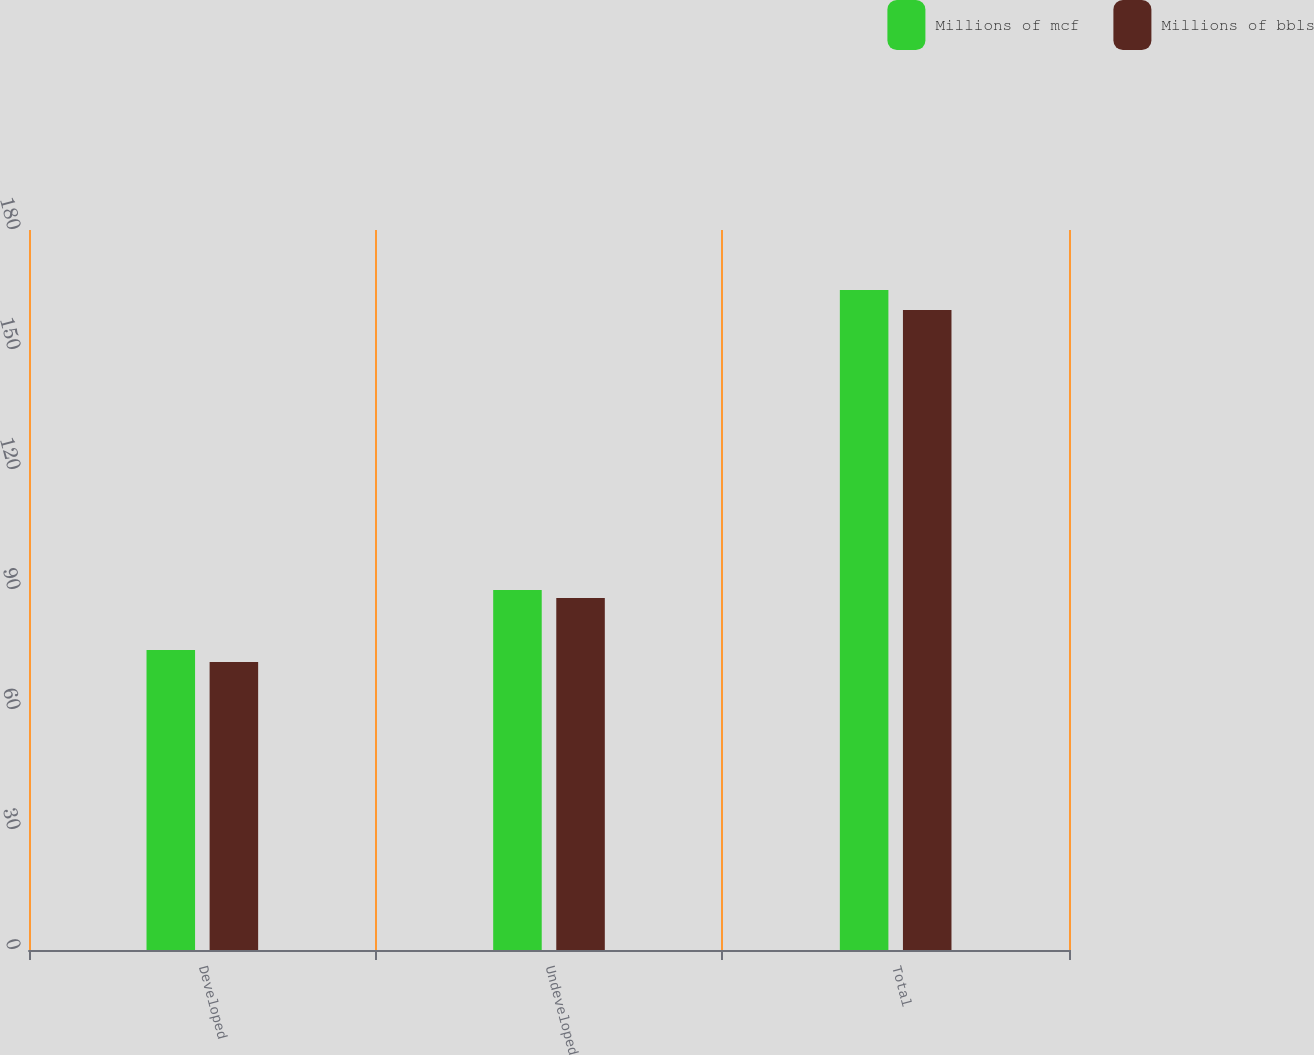Convert chart. <chart><loc_0><loc_0><loc_500><loc_500><stacked_bar_chart><ecel><fcel>Developed<fcel>Undeveloped<fcel>Total<nl><fcel>Millions of mcf<fcel>75<fcel>90<fcel>165<nl><fcel>Millions of bbls<fcel>72<fcel>88<fcel>160<nl></chart> 